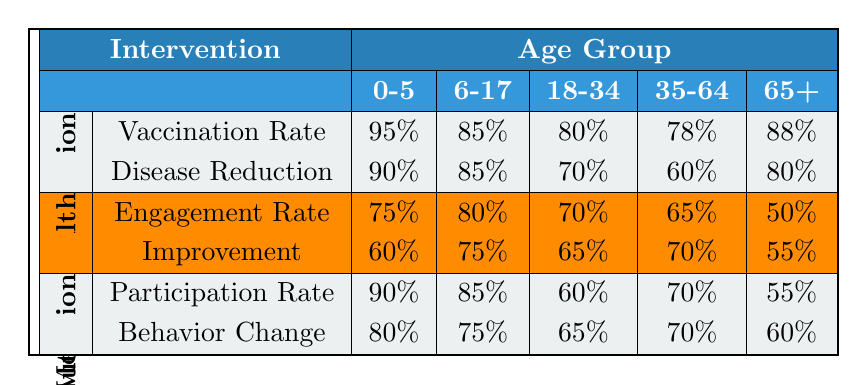What is the vaccination rate for the age group 6-17? The table indicates the vaccination rate for the age group 6-17 under the "Vaccination" intervention, which is directly listed as 85%.
Answer: 85% What is the improvement rate for the age group 35-64 in the Mental Health intervention? The table shows that the improvement rate for the age group 35-64 under the "Mental Health" intervention is listed as 70%.
Answer: 70% Which age group has the highest participation rate in Nutrition Education? The participation rates for all age groups under the "Nutrition Education" intervention are listed. The highest rate is 90% for the age group 0-5.
Answer: 0-5 Is the disease reduction for age group 18-34 greater than that for age group 35-64? The disease reduction for age group 18-34 is 70%, while for age group 35-64, it is 60%. Since 70% is greater than 60%, the answer is yes.
Answer: Yes What is the average vaccination rate across all age groups? The vaccination rates are 95%, 85%, 80%, 78%, and 88%. Adding these gives a sum of 426. There are 5 age groups, so the average is 426/5 = 85.2%.
Answer: 85.2% Does the engagement rate in Mental Health programs increase or decrease with age? By comparing the engagement rates of each age group, the rates are 75% (0-5), 80% (6-17), 70% (18-34), 65% (35-64), and 50% (65+). The rates initially increase until age 6-17 and then decrease thereafter.
Answer: Decrease How much higher is the disease reduction for age group 0-5 compared to age group 35-64? The disease reduction for age group 0-5 is 90%, and for age group 35-64, it is 60%. The difference is 90% - 60% = 30%.
Answer: 30% Which intervention has the lowest engagement rate for the age group 65+? Under the "Mental Health" intervention for the age group 65+, the engagement rate is 50%. For "Vaccination" and "Nutrition Education," the engagement rates do not apply. Therefore, the lowest is from the Mental Health intervention.
Answer: Mental Health What percentage of improvement is seen in the 6-17 age group for Mental Health programs? The table shows that the improvement for the age group 6-17 in Mental Health programs is 75%. This is directly provided in the table.
Answer: 75% Compare the behavior change percentage of the age group 18-34 in Nutrition Education with the improvement percentage of the same age group in Mental Health programs. The behavior change percentage for age group 18-34 in Nutrition Education is 65%. The improvement percentage for the same age group in Mental Health programs is also 65%. They are equal.
Answer: Equal 